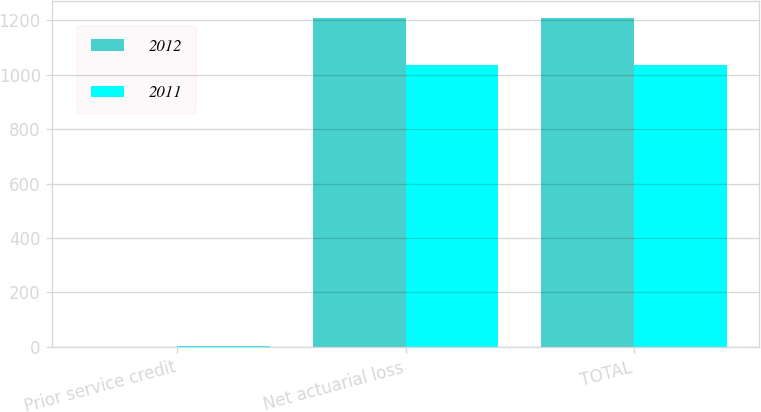<chart> <loc_0><loc_0><loc_500><loc_500><stacked_bar_chart><ecel><fcel>Prior service credit<fcel>Net actuarial loss<fcel>TOTAL<nl><fcel>2012<fcel>0.3<fcel>1210.7<fcel>1210.3<nl><fcel>2011<fcel>2.1<fcel>1038<fcel>1035.8<nl></chart> 